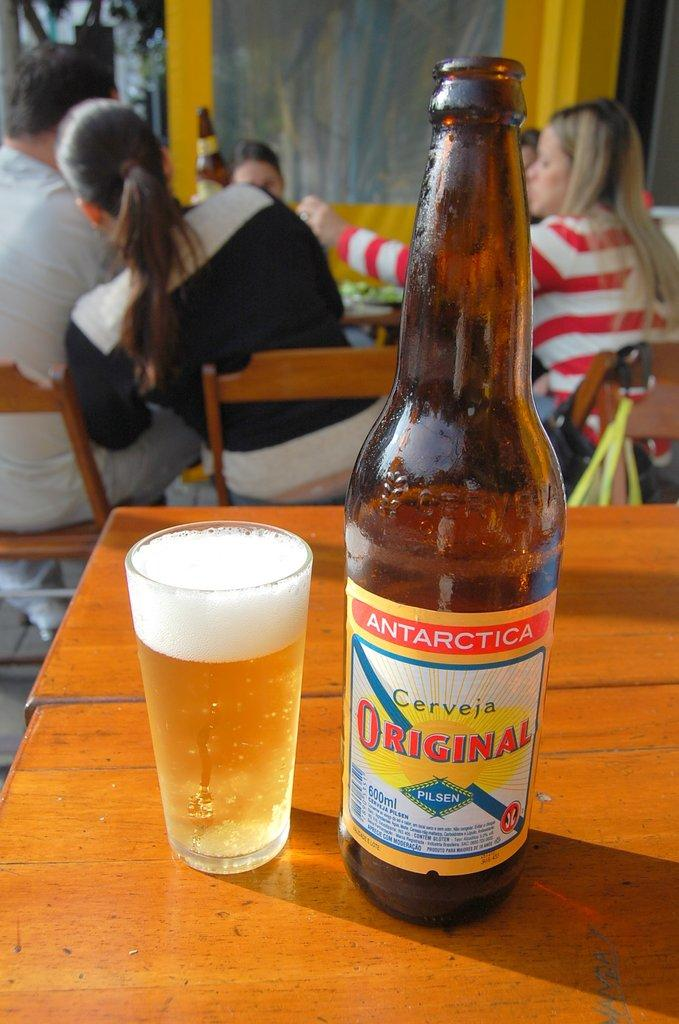<image>
Give a short and clear explanation of the subsequent image. A 600 ml bottle of Pilsen from Antarctica positioned next to a full glass. 